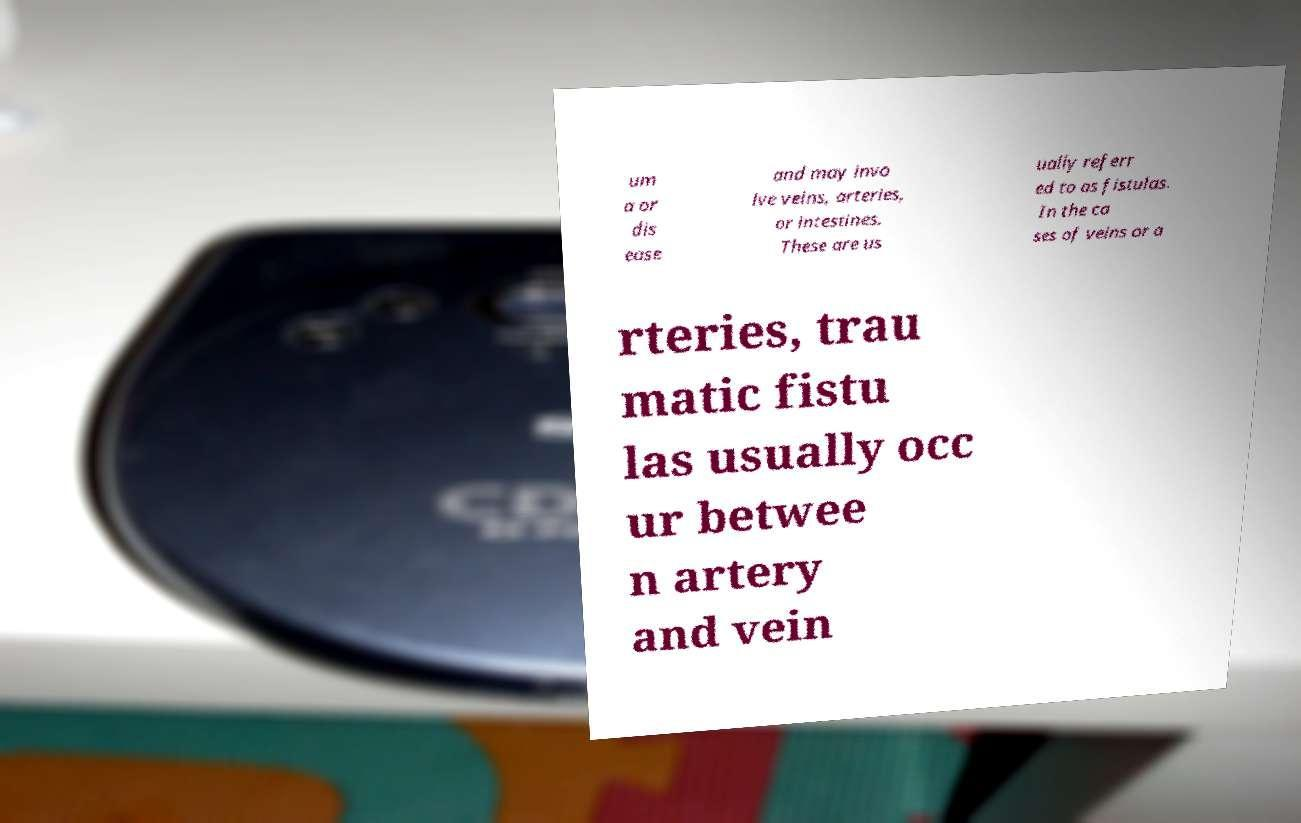Can you read and provide the text displayed in the image?This photo seems to have some interesting text. Can you extract and type it out for me? um a or dis ease and may invo lve veins, arteries, or intestines. These are us ually referr ed to as fistulas. In the ca ses of veins or a rteries, trau matic fistu las usually occ ur betwee n artery and vein 